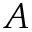<formula> <loc_0><loc_0><loc_500><loc_500>A</formula> 